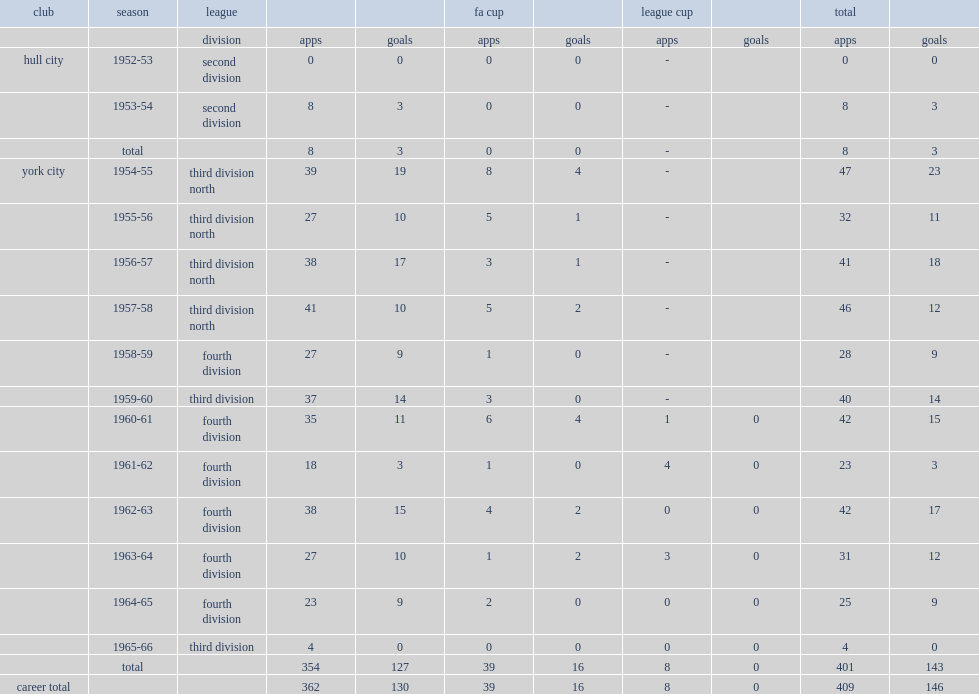How many goals did wilkinson in york's score in all competitions? 143.0. 